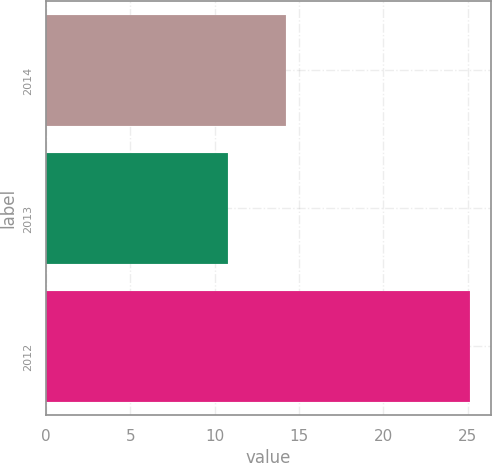Convert chart. <chart><loc_0><loc_0><loc_500><loc_500><bar_chart><fcel>2014<fcel>2013<fcel>2012<nl><fcel>14.2<fcel>10.8<fcel>25.1<nl></chart> 